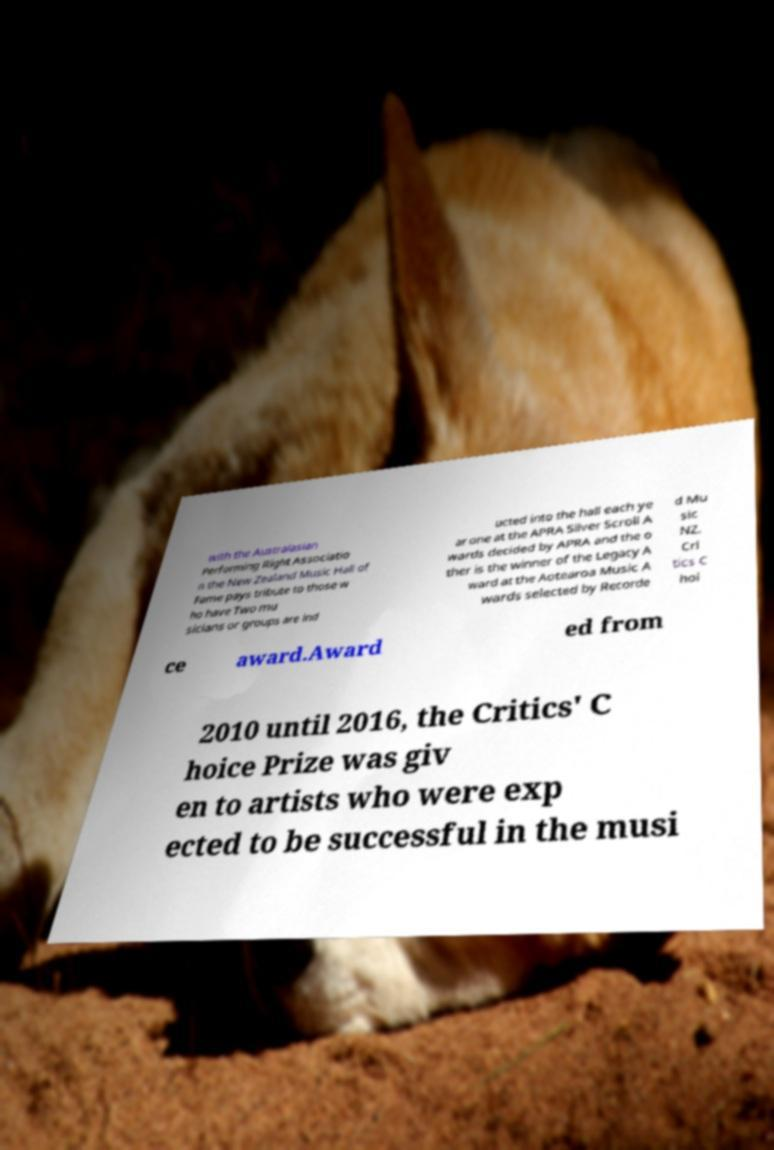There's text embedded in this image that I need extracted. Can you transcribe it verbatim? with the Australasian Performing Right Associatio n the New Zealand Music Hall of Fame pays tribute to those w ho have Two mu sicians or groups are ind ucted into the hall each ye ar one at the APRA Silver Scroll A wards decided by APRA and the o ther is the winner of the Legacy A ward at the Aotearoa Music A wards selected by Recorde d Mu sic NZ. Cri tics C hoi ce award.Award ed from 2010 until 2016, the Critics' C hoice Prize was giv en to artists who were exp ected to be successful in the musi 